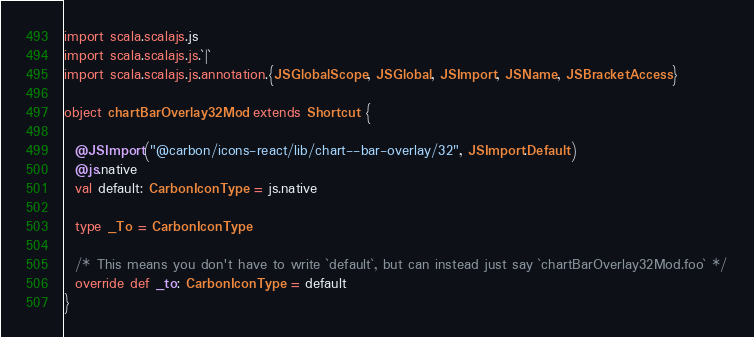Convert code to text. <code><loc_0><loc_0><loc_500><loc_500><_Scala_>import scala.scalajs.js
import scala.scalajs.js.`|`
import scala.scalajs.js.annotation.{JSGlobalScope, JSGlobal, JSImport, JSName, JSBracketAccess}

object chartBarOverlay32Mod extends Shortcut {
  
  @JSImport("@carbon/icons-react/lib/chart--bar-overlay/32", JSImport.Default)
  @js.native
  val default: CarbonIconType = js.native
  
  type _To = CarbonIconType
  
  /* This means you don't have to write `default`, but can instead just say `chartBarOverlay32Mod.foo` */
  override def _to: CarbonIconType = default
}
</code> 